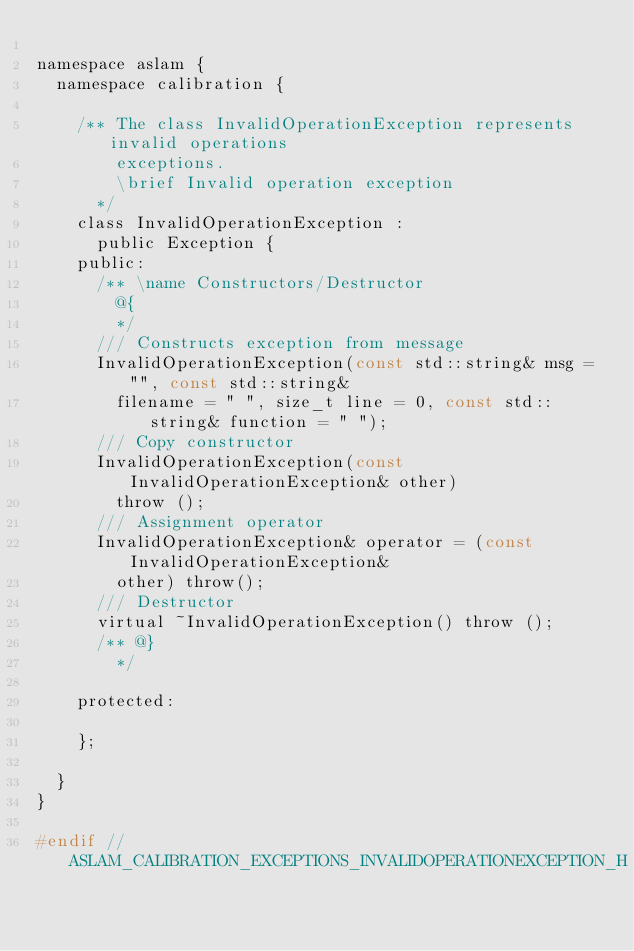Convert code to text. <code><loc_0><loc_0><loc_500><loc_500><_C_>
namespace aslam {
  namespace calibration {

    /** The class InvalidOperationException represents invalid operations
        exceptions.
        \brief Invalid operation exception
      */
    class InvalidOperationException :
      public Exception {
    public:
      /** \name Constructors/Destructor
        @{
        */
      /// Constructs exception from message
      InvalidOperationException(const std::string& msg = "", const std::string&
        filename = " ", size_t line = 0, const std::string& function = " ");
      /// Copy constructor
      InvalidOperationException(const InvalidOperationException& other)
        throw ();
      /// Assignment operator
      InvalidOperationException& operator = (const InvalidOperationException&
        other) throw();
      /// Destructor
      virtual ~InvalidOperationException() throw ();
      /** @}
        */

    protected:

    };

  }
}

#endif // ASLAM_CALIBRATION_EXCEPTIONS_INVALIDOPERATIONEXCEPTION_H
</code> 